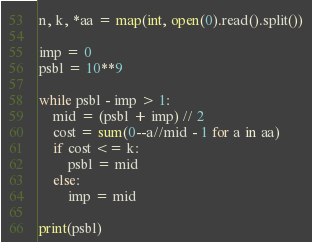Convert code to text. <code><loc_0><loc_0><loc_500><loc_500><_Python_>n, k, *aa = map(int, open(0).read().split())

imp = 0
psbl = 10**9

while psbl - imp > 1:
    mid = (psbl + imp) // 2
    cost = sum(0--a//mid - 1 for a in aa)
    if cost <= k:
        psbl = mid
    else:
        imp = mid

print(psbl)</code> 